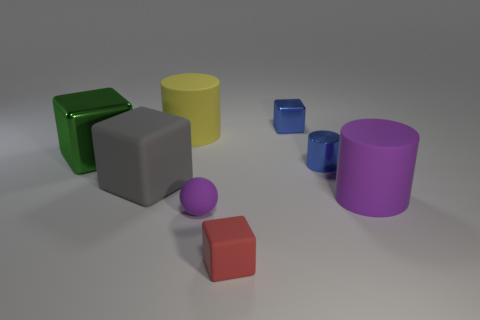Subtract all tiny red cubes. How many cubes are left? 3 Add 2 big matte blocks. How many objects exist? 10 Subtract all cylinders. How many objects are left? 5 Subtract all blue cylinders. How many cylinders are left? 2 Subtract 1 balls. How many balls are left? 0 Add 6 metal cubes. How many metal cubes are left? 8 Add 2 blue metal cubes. How many blue metal cubes exist? 3 Subtract 0 green cylinders. How many objects are left? 8 Subtract all cyan cubes. Subtract all cyan balls. How many cubes are left? 4 Subtract all large purple cylinders. Subtract all tiny blue metallic blocks. How many objects are left? 6 